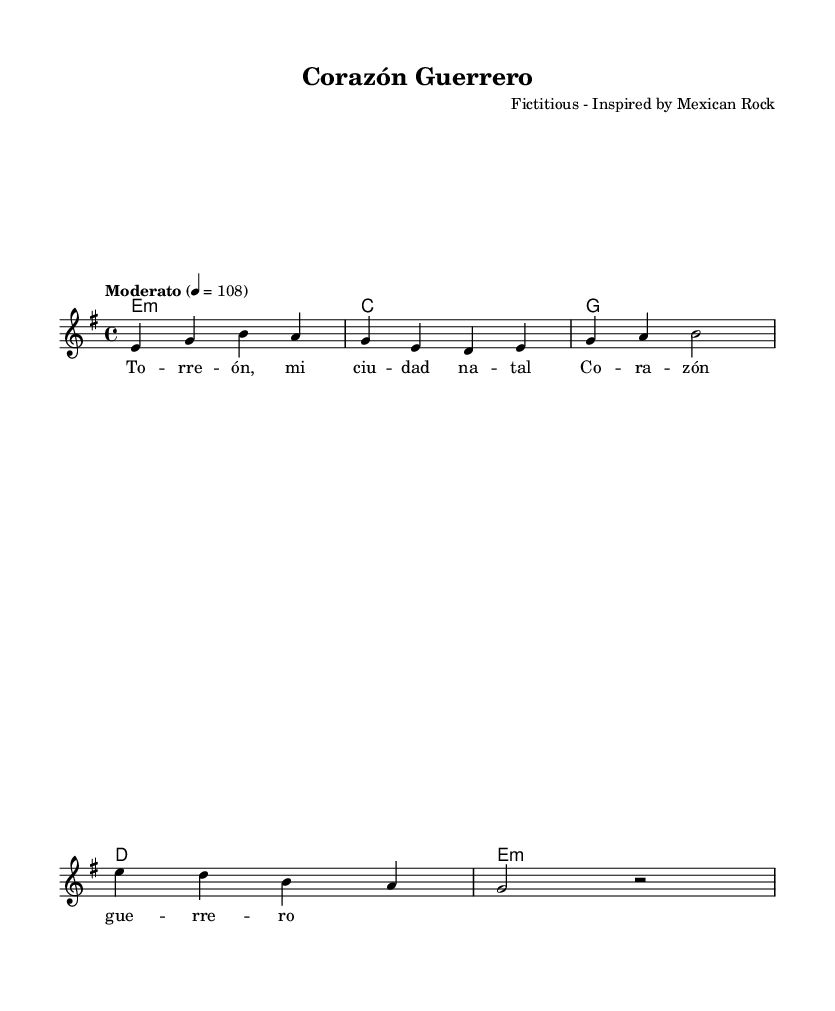What is the key signature of this music? The key signature is indicated with the presence of one sharp (F#) or no accidentals in the key of E minor, as seen in the provided information.
Answer: E minor What is the time signature of this music? The time signature is specified as 4/4, meaning there are four beats in each measure, which can be observed in the rhythmic structure of the score.
Answer: 4/4 What is the tempo marking for this piece? The tempo marking indicates a moderate speed, specifically noted as "Moderato" and marked at 108 beats per minute within the music details.
Answer: Moderato How many measures are in the melody section? By counting the distinct bars, it can be determined that the melody consists of 5 measures, based on the division of musical phrases shown.
Answer: 5 What type of song structure does "Corazón Guerrero" represent? The song exhibits a verse structure based on lyrics that celebrate hometown pride, which typically characterizes classic Mexican rock songs about loyalty.
Answer: Verse What is the name of the song? The title is explicitly stated in the header section of the music, which shows the name given to this piece.
Answer: Corazón Guerrero What is the composer credited for this music? The composer name is included in the header section, where it specifies that this piece is fictitiously composed by an unnamed artist inspired by Mexican rock.
Answer: Fictitious 